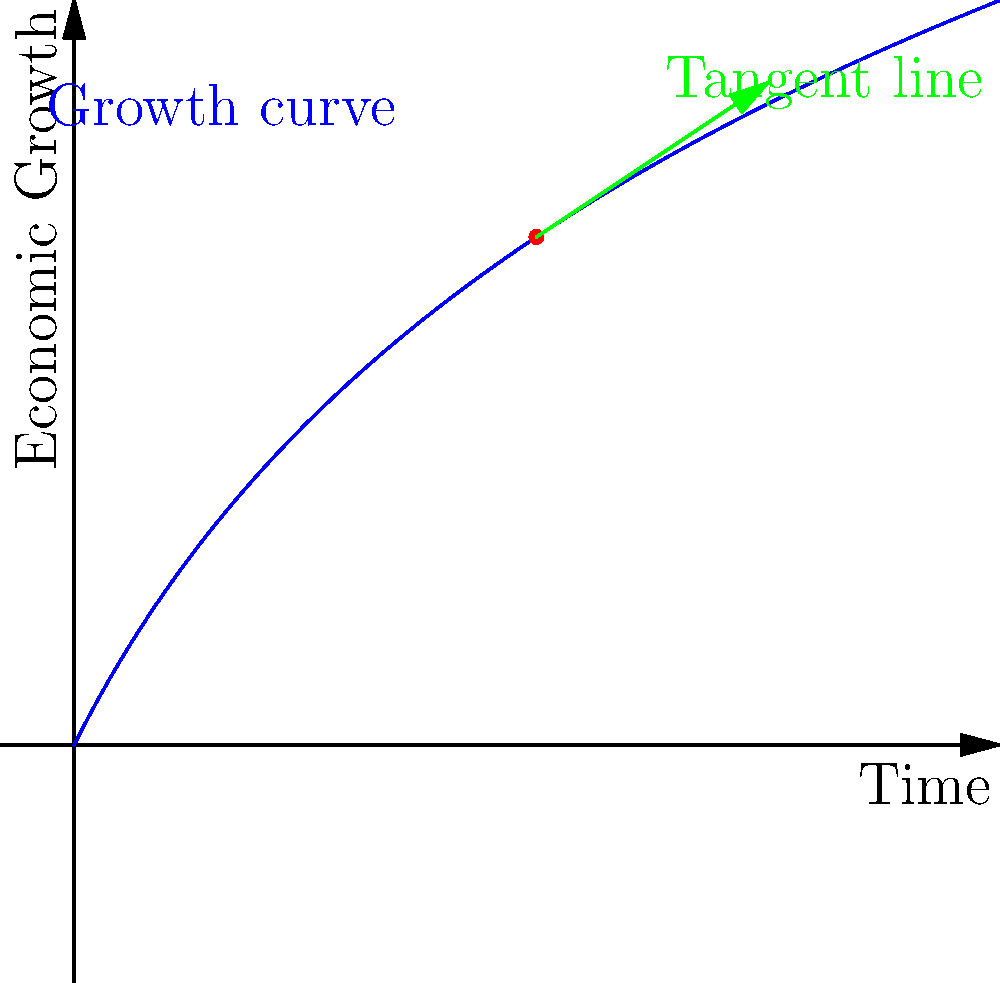In Jason Zweig's analysis of economic growth, he often discusses the rate of change at specific points in time. Consider the curve shown in the graph, which represents economic growth over time. At the point $(2, f(2))$, what is the slope of the tangent line to this curve? To find the slope of the tangent line at the point $(2, f(2))$, we need to follow these steps:

1) The curve is given by the function $f(x) = 2\ln(x+1)$, where $x$ represents time and $f(x)$ represents economic growth.

2) To find the slope of the tangent line, we need to calculate the derivative of $f(x)$ and evaluate it at $x=2$.

3) The derivative of $f(x)$ is:
   $$f'(x) = \frac{d}{dx}[2\ln(x+1)] = \frac{2}{x+1}$$

4) Now, we evaluate $f'(x)$ at $x=2$:
   $$f'(2) = \frac{2}{2+1} = \frac{2}{3}$$

5) Therefore, the slope of the tangent line at the point $(2, f(2))$ is $\frac{2}{3}$.

This slope represents the instantaneous rate of change of economic growth at time $x=2$. In the context of Zweig's economic analysis, this would indicate the pace of economic growth at that specific point in time.
Answer: $\frac{2}{3}$ 